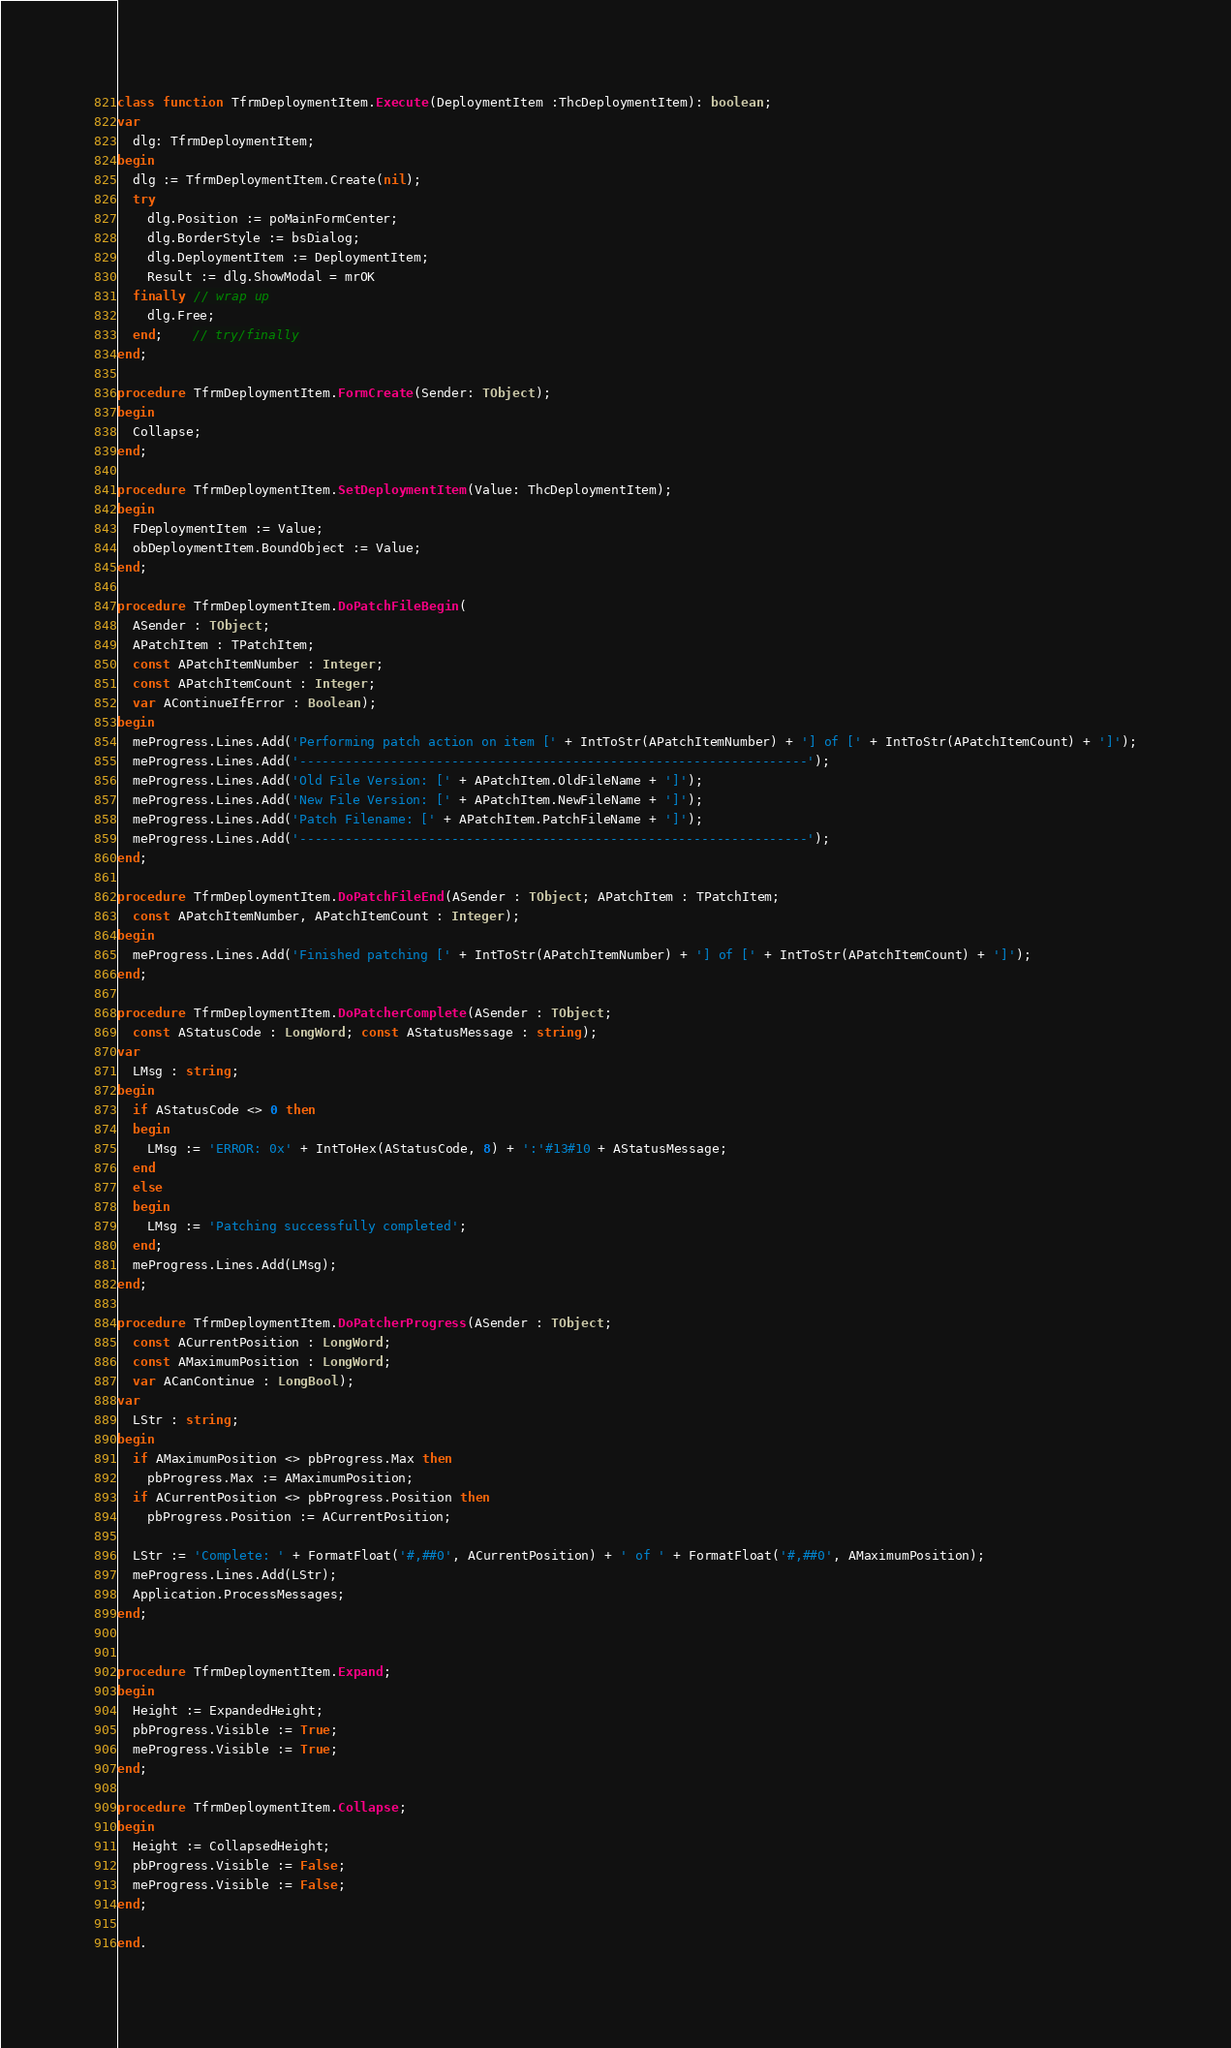<code> <loc_0><loc_0><loc_500><loc_500><_Pascal_>
class function TfrmDeploymentItem.Execute(DeploymentItem :ThcDeploymentItem): boolean;
var
  dlg: TfrmDeploymentItem;
begin
  dlg := TfrmDeploymentItem.Create(nil);
  try
    dlg.Position := poMainFormCenter;
    dlg.BorderStyle := bsDialog;
    dlg.DeploymentItem := DeploymentItem;
    Result := dlg.ShowModal = mrOK
  finally // wrap up
    dlg.Free;
  end;    // try/finally
end;

procedure TfrmDeploymentItem.FormCreate(Sender: TObject);
begin
  Collapse;
end;

procedure TfrmDeploymentItem.SetDeploymentItem(Value: ThcDeploymentItem);
begin
  FDeploymentItem := Value;
  obDeploymentItem.BoundObject := Value;
end;

procedure TfrmDeploymentItem.DoPatchFileBegin(
  ASender : TObject;
  APatchItem : TPatchItem;
  const APatchItemNumber : Integer;
  const APatchItemCount : Integer;
  var AContinueIfError : Boolean);
begin
  meProgress.Lines.Add('Performing patch action on item [' + IntToStr(APatchItemNumber) + '] of [' + IntToStr(APatchItemCount) + ']');
  meProgress.Lines.Add('-------------------------------------------------------------------');
  meProgress.Lines.Add('Old File Version: [' + APatchItem.OldFileName + ']');
  meProgress.Lines.Add('New File Version: [' + APatchItem.NewFileName + ']');
  meProgress.Lines.Add('Patch Filename: [' + APatchItem.PatchFileName + ']');
  meProgress.Lines.Add('-------------------------------------------------------------------');
end;

procedure TfrmDeploymentItem.DoPatchFileEnd(ASender : TObject; APatchItem : TPatchItem;
  const APatchItemNumber, APatchItemCount : Integer);
begin
  meProgress.Lines.Add('Finished patching [' + IntToStr(APatchItemNumber) + '] of [' + IntToStr(APatchItemCount) + ']');
end;

procedure TfrmDeploymentItem.DoPatcherComplete(ASender : TObject;
  const AStatusCode : LongWord; const AStatusMessage : string);
var
  LMsg : string;
begin
  if AStatusCode <> 0 then
  begin
    LMsg := 'ERROR: 0x' + IntToHex(AStatusCode, 8) + ':'#13#10 + AStatusMessage;
  end
  else
  begin
    LMsg := 'Patching successfully completed';
  end;
  meProgress.Lines.Add(LMsg);
end;

procedure TfrmDeploymentItem.DoPatcherProgress(ASender : TObject;
  const ACurrentPosition : LongWord;
  const AMaximumPosition : LongWord;
  var ACanContinue : LongBool);
var
  LStr : string;
begin
  if AMaximumPosition <> pbProgress.Max then
    pbProgress.Max := AMaximumPosition;
  if ACurrentPosition <> pbProgress.Position then
    pbProgress.Position := ACurrentPosition;

  LStr := 'Complete: ' + FormatFloat('#,##0', ACurrentPosition) + ' of ' + FormatFloat('#,##0', AMaximumPosition);
  meProgress.Lines.Add(LStr);
  Application.ProcessMessages;
end;


procedure TfrmDeploymentItem.Expand;
begin
  Height := ExpandedHeight;
  pbProgress.Visible := True;
  meProgress.Visible := True;
end;

procedure TfrmDeploymentItem.Collapse;
begin
  Height := CollapsedHeight;
  pbProgress.Visible := False;
  meProgress.Visible := False;
end;

end.

</code> 